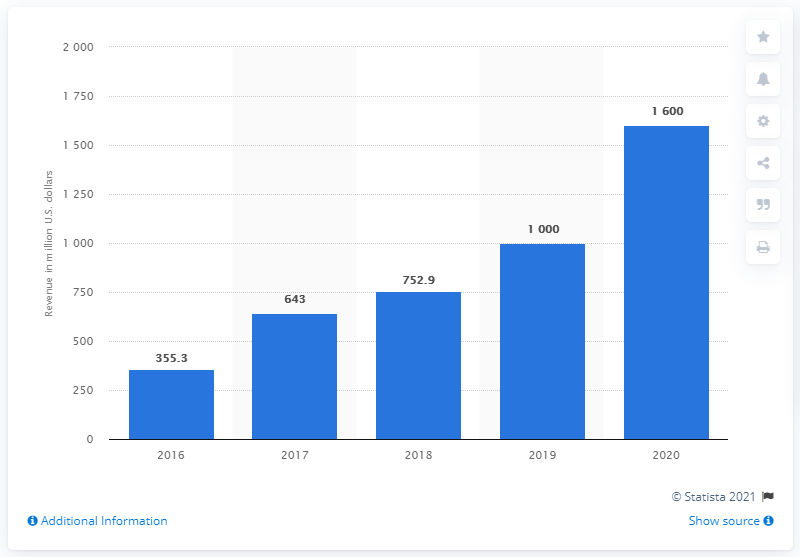What was Snapchat's social networking revenue in the United States in 2020? In 2020, Snapchat generated a revenue of $1,600 million from its social networking operations in the United States, reflecting a significant growth compared to previous years as seen in the provided bar chart. 